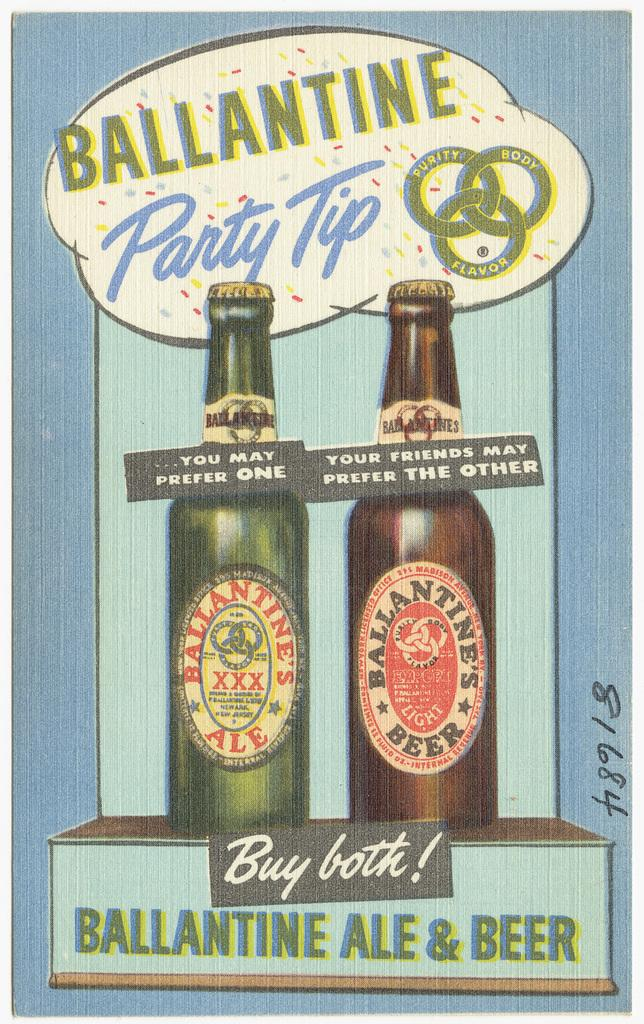<image>
Create a compact narrative representing the image presented. An Ad for Ballantine Ale beer says buy both! 